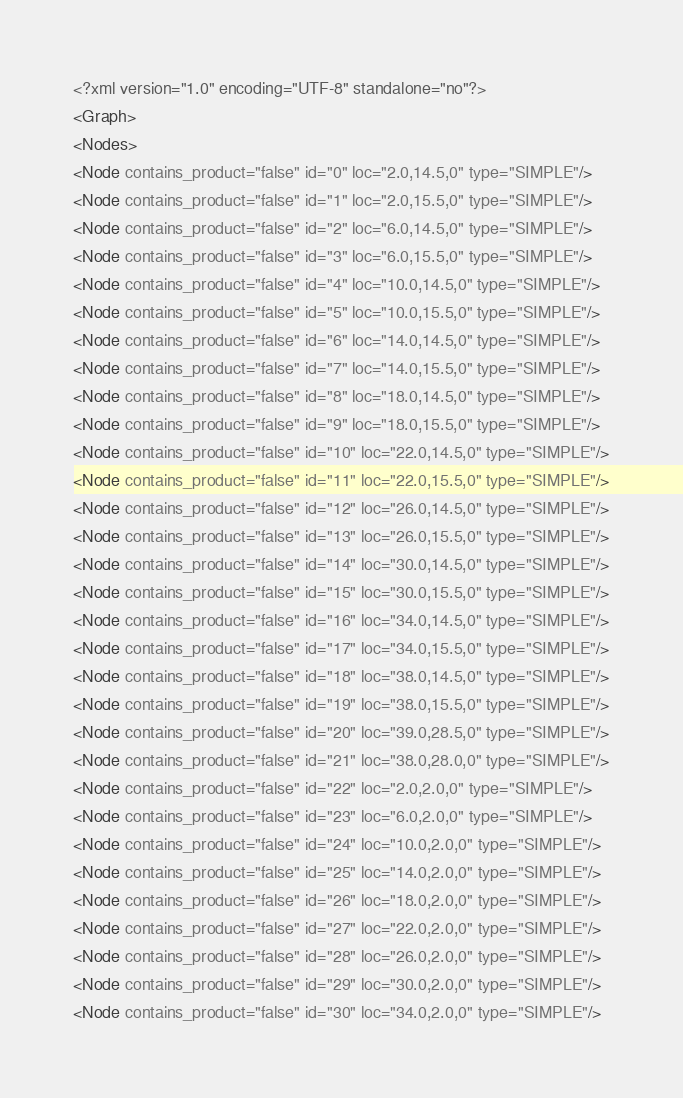<code> <loc_0><loc_0><loc_500><loc_500><_XML_><?xml version="1.0" encoding="UTF-8" standalone="no"?>
<Graph>
<Nodes>
<Node contains_product="false" id="0" loc="2.0,14.5,0" type="SIMPLE"/>
<Node contains_product="false" id="1" loc="2.0,15.5,0" type="SIMPLE"/>
<Node contains_product="false" id="2" loc="6.0,14.5,0" type="SIMPLE"/>
<Node contains_product="false" id="3" loc="6.0,15.5,0" type="SIMPLE"/>
<Node contains_product="false" id="4" loc="10.0,14.5,0" type="SIMPLE"/>
<Node contains_product="false" id="5" loc="10.0,15.5,0" type="SIMPLE"/>
<Node contains_product="false" id="6" loc="14.0,14.5,0" type="SIMPLE"/>
<Node contains_product="false" id="7" loc="14.0,15.5,0" type="SIMPLE"/>
<Node contains_product="false" id="8" loc="18.0,14.5,0" type="SIMPLE"/>
<Node contains_product="false" id="9" loc="18.0,15.5,0" type="SIMPLE"/>
<Node contains_product="false" id="10" loc="22.0,14.5,0" type="SIMPLE"/>
<Node contains_product="false" id="11" loc="22.0,15.5,0" type="SIMPLE"/>
<Node contains_product="false" id="12" loc="26.0,14.5,0" type="SIMPLE"/>
<Node contains_product="false" id="13" loc="26.0,15.5,0" type="SIMPLE"/>
<Node contains_product="false" id="14" loc="30.0,14.5,0" type="SIMPLE"/>
<Node contains_product="false" id="15" loc="30.0,15.5,0" type="SIMPLE"/>
<Node contains_product="false" id="16" loc="34.0,14.5,0" type="SIMPLE"/>
<Node contains_product="false" id="17" loc="34.0,15.5,0" type="SIMPLE"/>
<Node contains_product="false" id="18" loc="38.0,14.5,0" type="SIMPLE"/>
<Node contains_product="false" id="19" loc="38.0,15.5,0" type="SIMPLE"/>
<Node contains_product="false" id="20" loc="39.0,28.5,0" type="SIMPLE"/>
<Node contains_product="false" id="21" loc="38.0,28.0,0" type="SIMPLE"/>
<Node contains_product="false" id="22" loc="2.0,2.0,0" type="SIMPLE"/>
<Node contains_product="false" id="23" loc="6.0,2.0,0" type="SIMPLE"/>
<Node contains_product="false" id="24" loc="10.0,2.0,0" type="SIMPLE"/>
<Node contains_product="false" id="25" loc="14.0,2.0,0" type="SIMPLE"/>
<Node contains_product="false" id="26" loc="18.0,2.0,0" type="SIMPLE"/>
<Node contains_product="false" id="27" loc="22.0,2.0,0" type="SIMPLE"/>
<Node contains_product="false" id="28" loc="26.0,2.0,0" type="SIMPLE"/>
<Node contains_product="false" id="29" loc="30.0,2.0,0" type="SIMPLE"/>
<Node contains_product="false" id="30" loc="34.0,2.0,0" type="SIMPLE"/></code> 